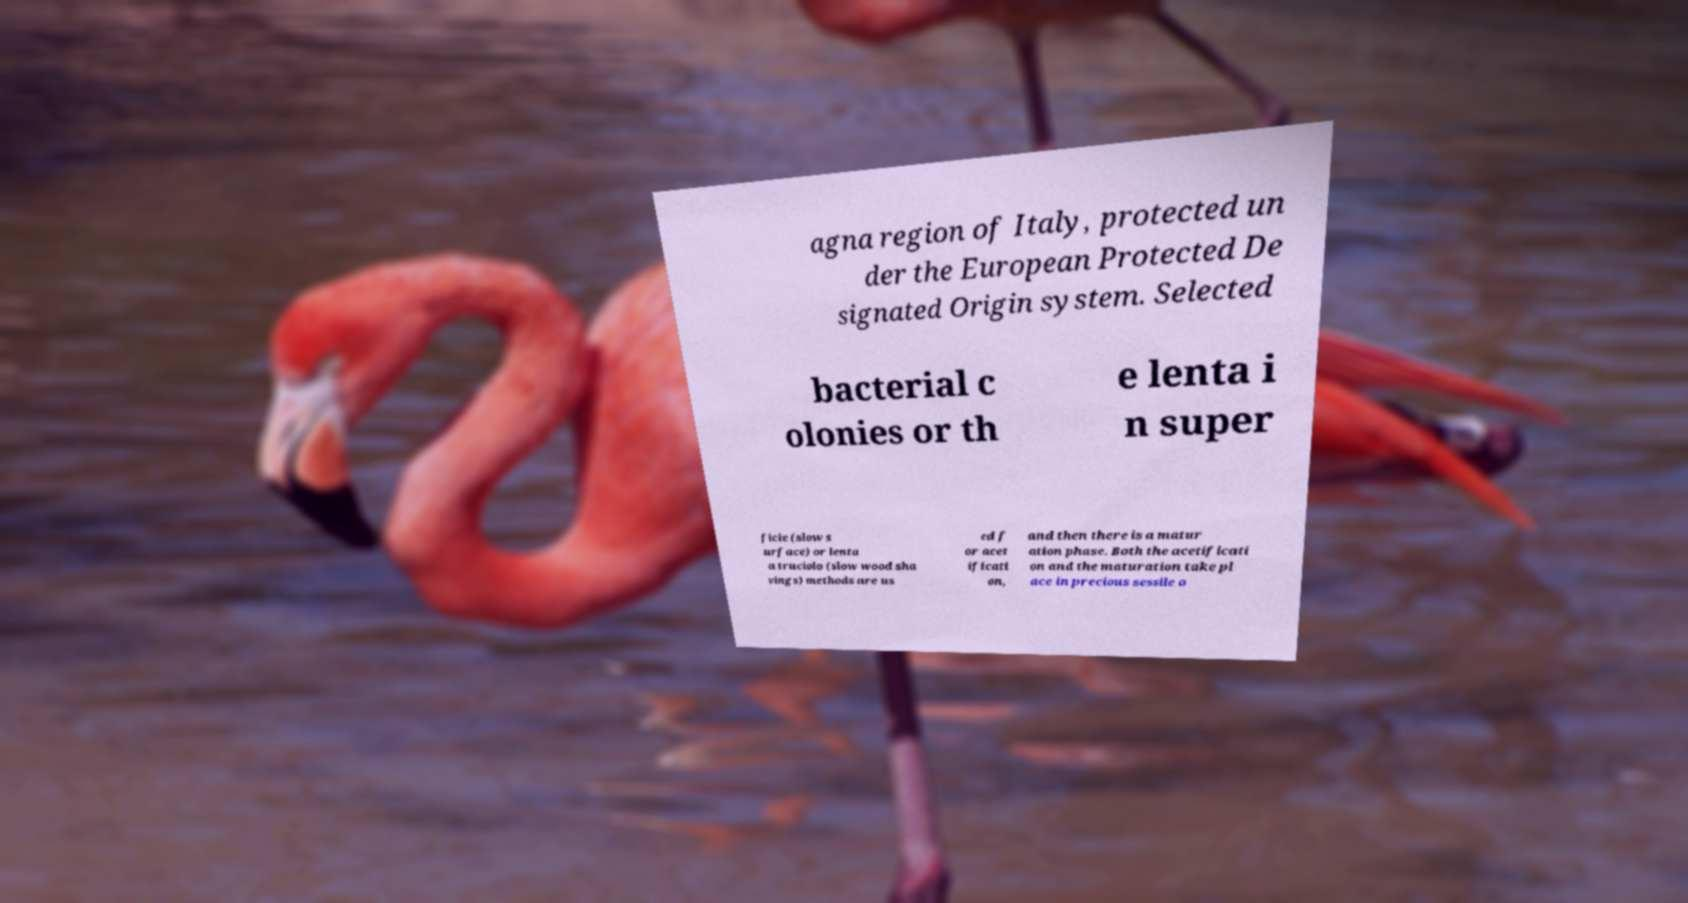Please read and relay the text visible in this image. What does it say? agna region of Italy, protected un der the European Protected De signated Origin system. Selected bacterial c olonies or th e lenta i n super ficie (slow s urface) or lenta a truciolo (slow wood sha vings) methods are us ed f or acet ificati on, and then there is a matur ation phase. Both the acetificati on and the maturation take pl ace in precious sessile o 